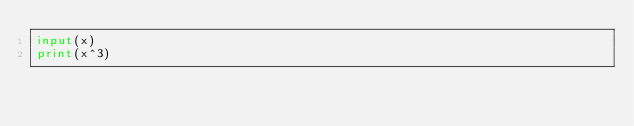Convert code to text. <code><loc_0><loc_0><loc_500><loc_500><_Python_>input(x)
print(x^3)
</code> 